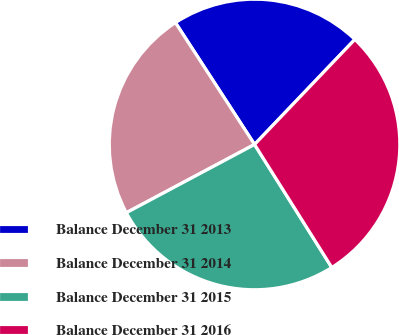Convert chart to OTSL. <chart><loc_0><loc_0><loc_500><loc_500><pie_chart><fcel>Balance December 31 2013<fcel>Balance December 31 2014<fcel>Balance December 31 2015<fcel>Balance December 31 2016<nl><fcel>21.3%<fcel>23.62%<fcel>26.14%<fcel>28.94%<nl></chart> 